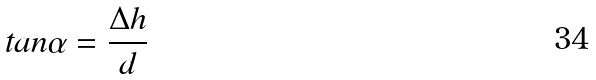<formula> <loc_0><loc_0><loc_500><loc_500>t a n \alpha = \frac { \Delta h } { d }</formula> 